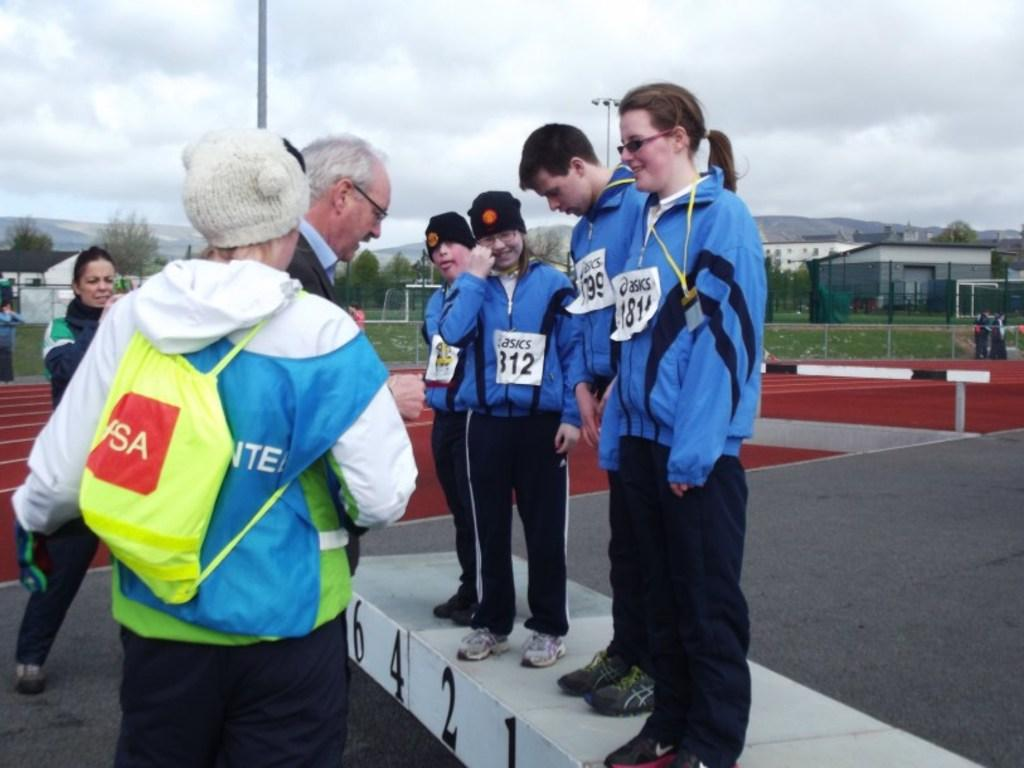<image>
Summarize the visual content of the image. Youth players receiving medals in blue jackets with asics on the white square tag. 